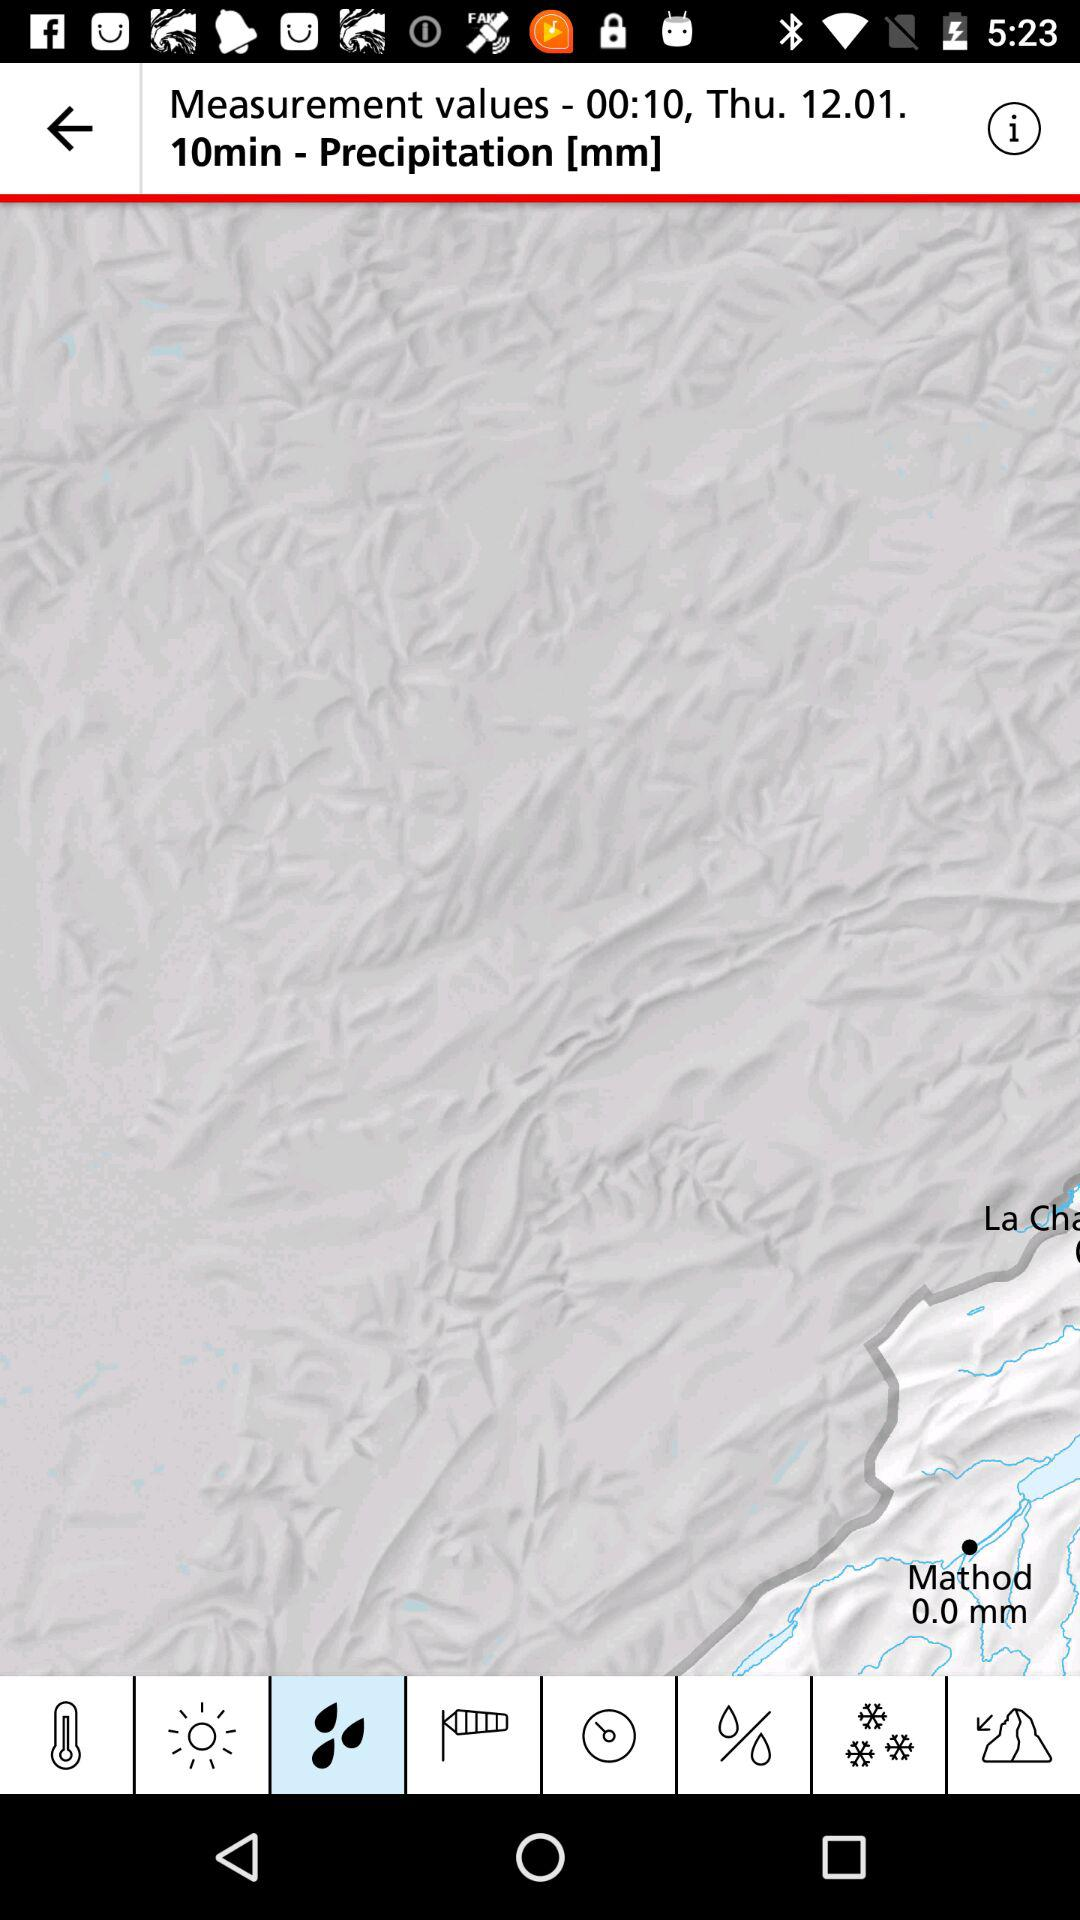What is the measurement unit of precipitation? The measurement unit of precipitation is mm. 